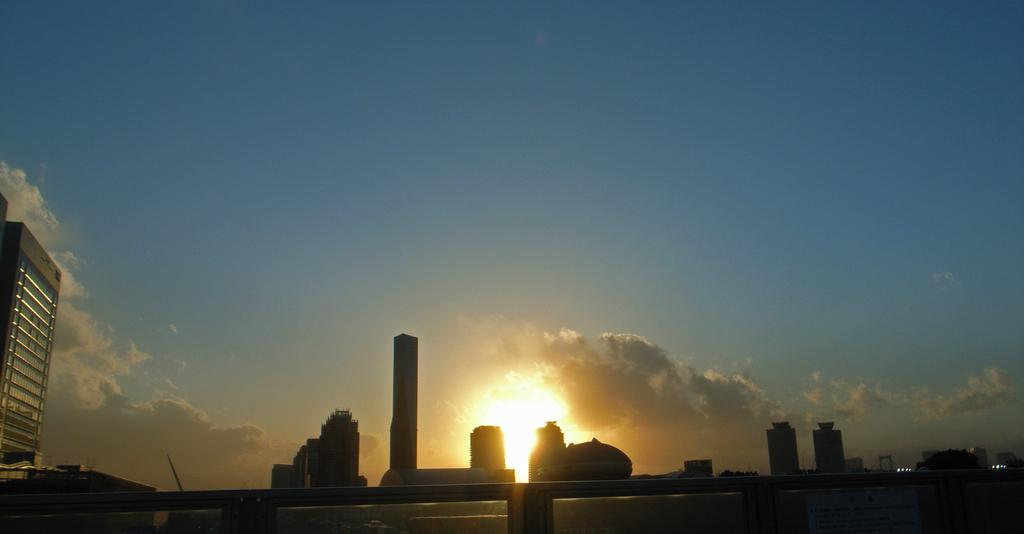What structure is located on the left side of the image? There is a building on the left side of the image. How many buildings can be seen in the image? There are multiple buildings in the image. What is visible in the sky in the image? The sky is visible in the image, and clouds and the sun are present. What type of harmony can be heard in the image? There is no audible harmony present in the image, as it is a visual representation of buildings and the sky. How many toes are visible on the buildings in the image? Buildings do not have toes, so none are visible in the image. 